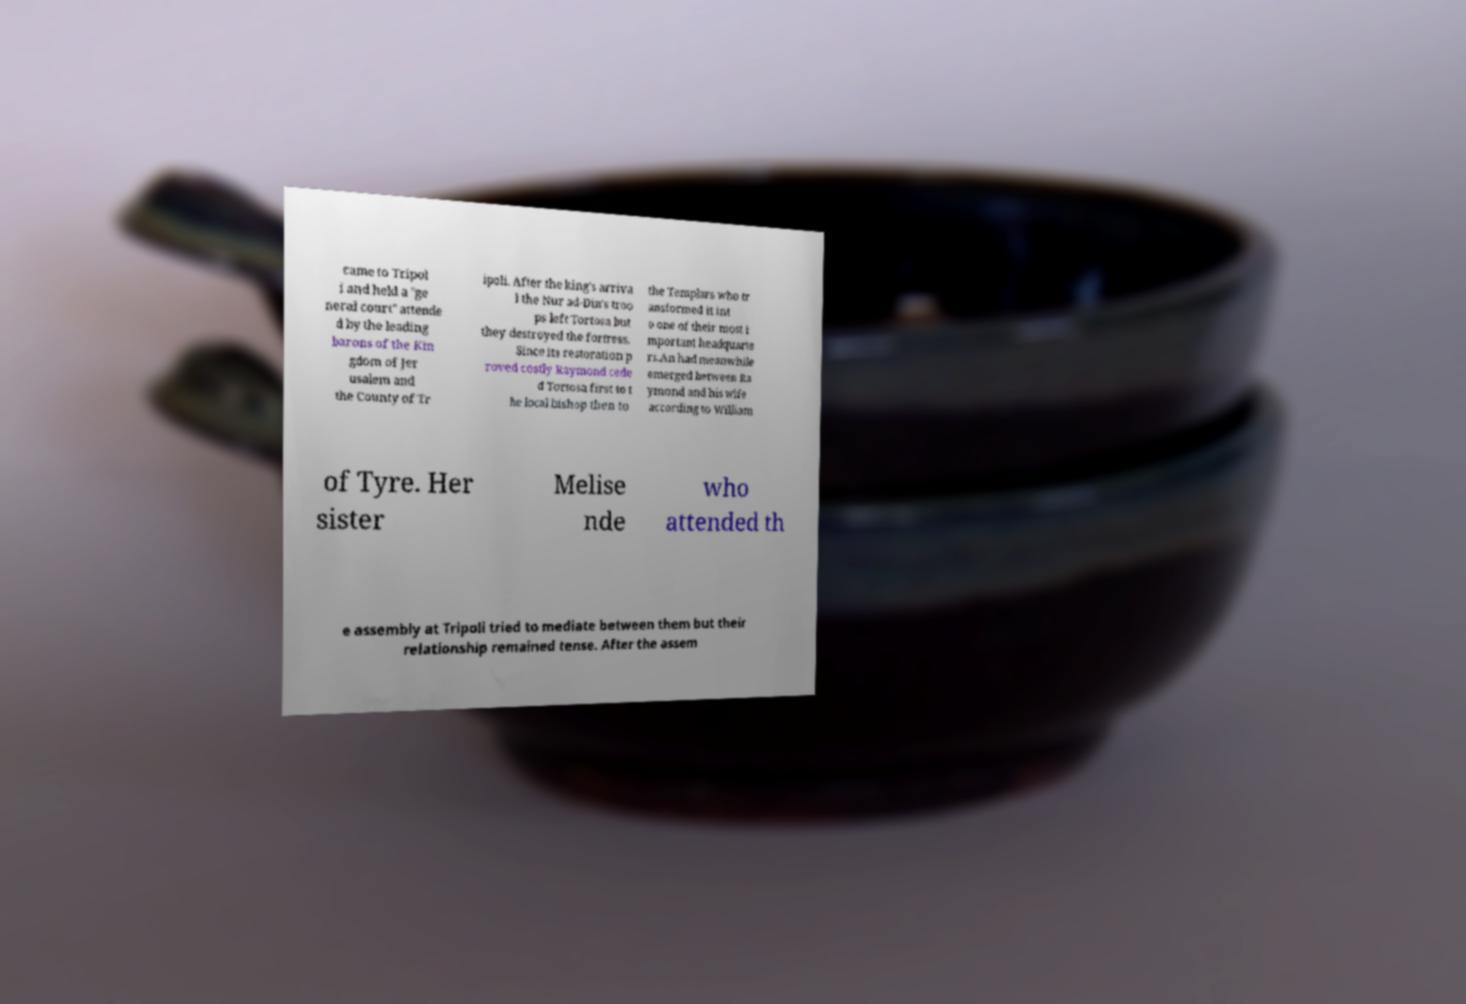Please identify and transcribe the text found in this image. came to Tripol i and held a "ge neral court" attende d by the leading barons of the Kin gdom of Jer usalem and the County of Tr ipoli. After the king's arriva l the Nur ad-Din's troo ps left Tortosa but they destroyed the fortress. Since its restoration p roved costly Raymond cede d Tortosa first to t he local bishop then to the Templars who tr ansformed it int o one of their most i mportant headquarte rs.An had meanwhile emerged between Ra ymond and his wife according to William of Tyre. Her sister Melise nde who attended th e assembly at Tripoli tried to mediate between them but their relationship remained tense. After the assem 